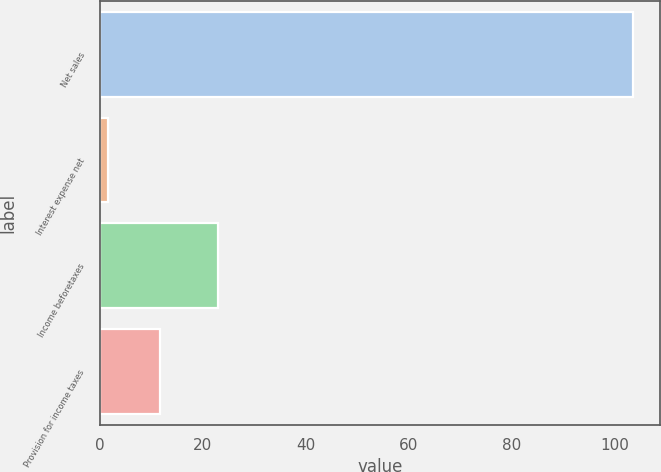<chart> <loc_0><loc_0><loc_500><loc_500><bar_chart><fcel>Net sales<fcel>Interest expense net<fcel>Income beforetaxes<fcel>Provision for income taxes<nl><fcel>103.6<fcel>1.5<fcel>22.9<fcel>11.71<nl></chart> 